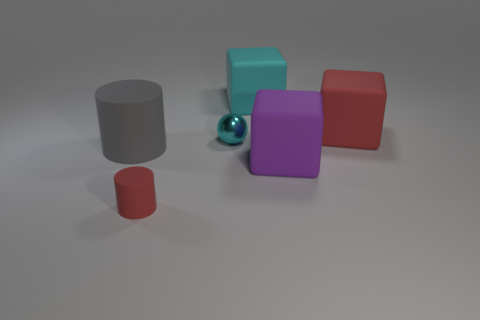Add 2 small things. How many objects exist? 8 Subtract all balls. How many objects are left? 5 Subtract all large yellow rubber cylinders. Subtract all tiny red cylinders. How many objects are left? 5 Add 5 small objects. How many small objects are left? 7 Add 6 large purple matte objects. How many large purple matte objects exist? 7 Subtract 0 yellow cubes. How many objects are left? 6 